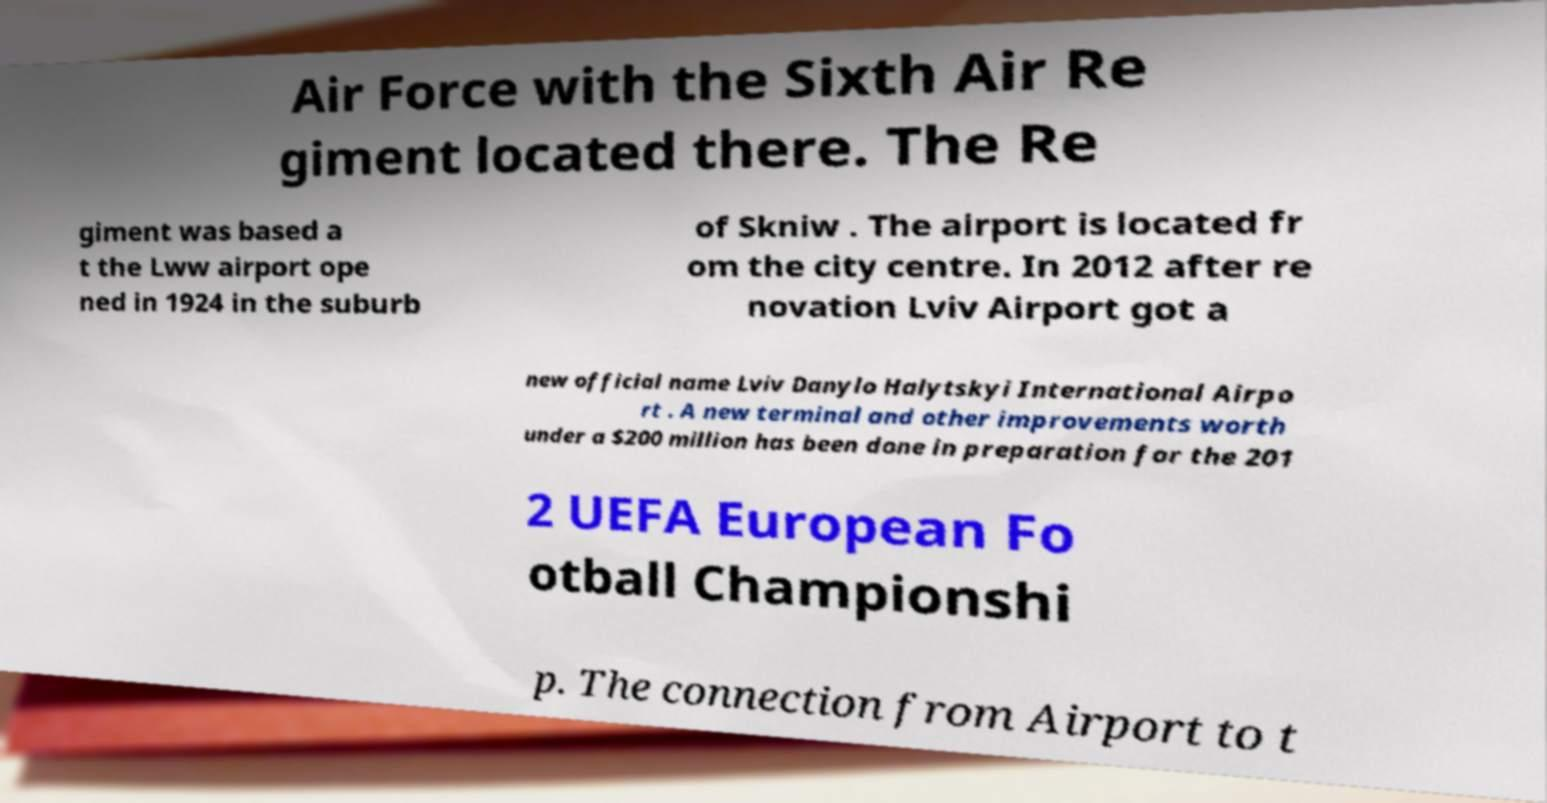I need the written content from this picture converted into text. Can you do that? Air Force with the Sixth Air Re giment located there. The Re giment was based a t the Lww airport ope ned in 1924 in the suburb of Skniw . The airport is located fr om the city centre. In 2012 after re novation Lviv Airport got a new official name Lviv Danylo Halytskyi International Airpo rt . A new terminal and other improvements worth under a $200 million has been done in preparation for the 201 2 UEFA European Fo otball Championshi p. The connection from Airport to t 